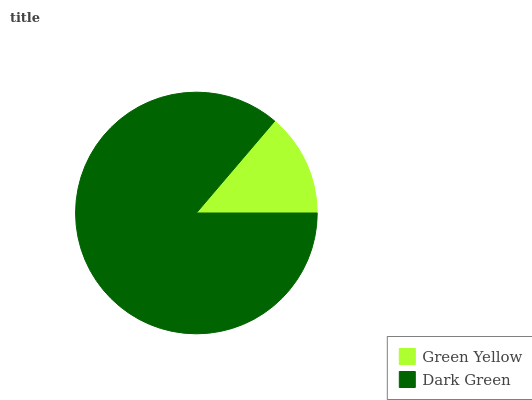Is Green Yellow the minimum?
Answer yes or no. Yes. Is Dark Green the maximum?
Answer yes or no. Yes. Is Dark Green the minimum?
Answer yes or no. No. Is Dark Green greater than Green Yellow?
Answer yes or no. Yes. Is Green Yellow less than Dark Green?
Answer yes or no. Yes. Is Green Yellow greater than Dark Green?
Answer yes or no. No. Is Dark Green less than Green Yellow?
Answer yes or no. No. Is Dark Green the high median?
Answer yes or no. Yes. Is Green Yellow the low median?
Answer yes or no. Yes. Is Green Yellow the high median?
Answer yes or no. No. Is Dark Green the low median?
Answer yes or no. No. 